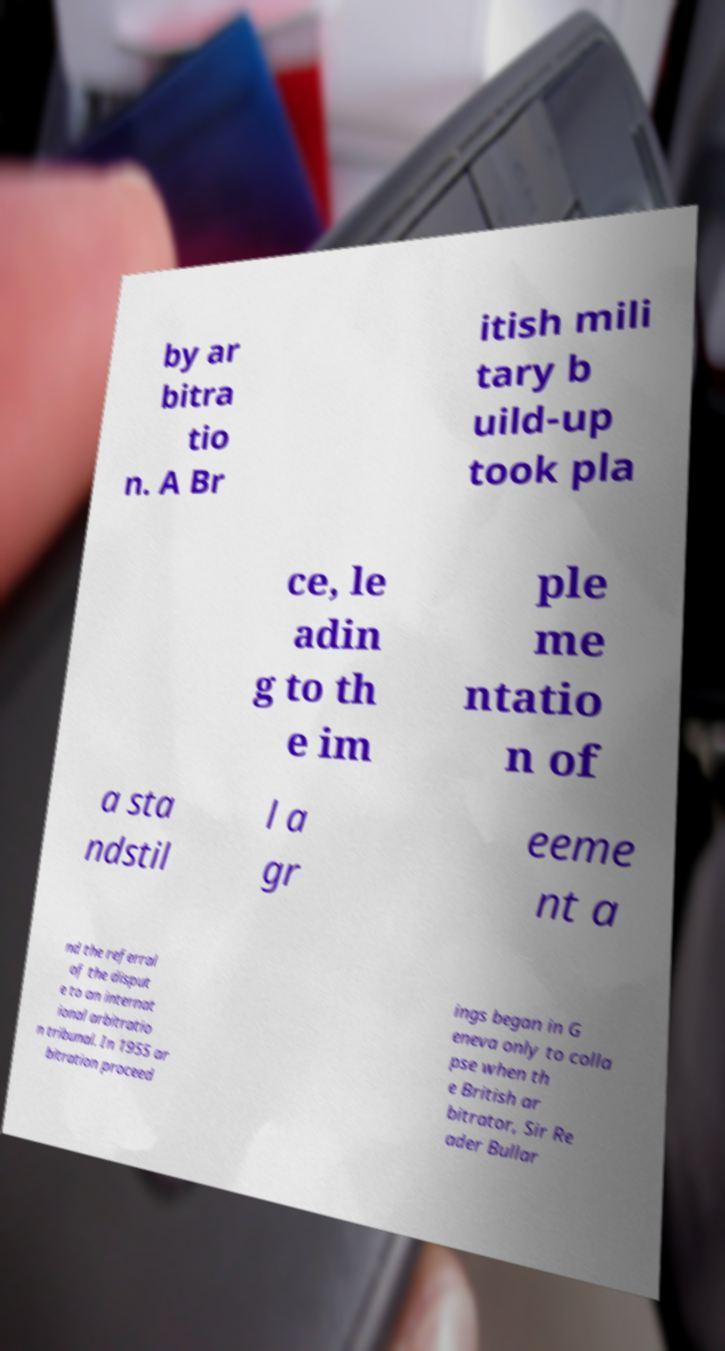Could you extract and type out the text from this image? by ar bitra tio n. A Br itish mili tary b uild-up took pla ce, le adin g to th e im ple me ntatio n of a sta ndstil l a gr eeme nt a nd the referral of the disput e to an internat ional arbitratio n tribunal. In 1955 ar bitration proceed ings began in G eneva only to colla pse when th e British ar bitrator, Sir Re ader Bullar 